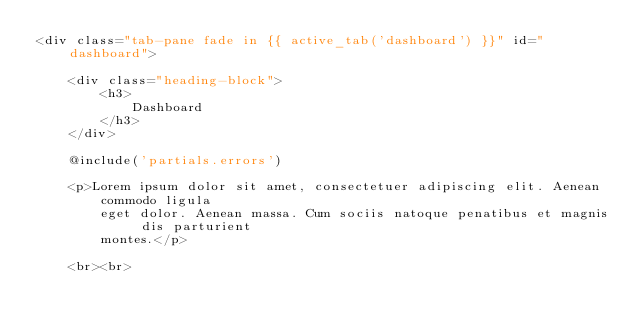Convert code to text. <code><loc_0><loc_0><loc_500><loc_500><_PHP_><div class="tab-pane fade in {{ active_tab('dashboard') }}" id="dashboard">

    <div class="heading-block">
        <h3>
            Dashboard
        </h3>
    </div>

    @include('partials.errors')

    <p>Lorem ipsum dolor sit amet, consectetuer adipiscing elit. Aenean commodo ligula
        eget dolor. Aenean massa. Cum sociis natoque penatibus et magnis dis parturient
        montes.</p>

    <br><br>
</code> 